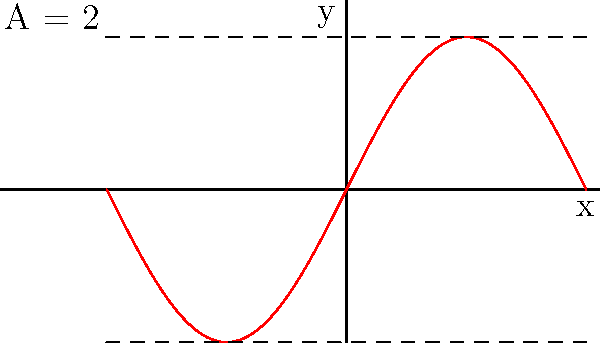Given the sine wave function $f(x) = 2\sin(x)$ plotted above, determine the amplitude of the wave. How would this amplitude change if the function was modified to $g(x) = 3\sin(x)$? To solve this problem, let's follow these steps:

1. Recall that the amplitude of a sine wave is the maximum vertical distance from the midline to the peak (or trough) of the wave.

2. For the given function $f(x) = 2\sin(x)$:
   - The coefficient of $\sin(x)$ is 2.
   - This coefficient determines the amplitude of the wave.
   - Therefore, the amplitude of $f(x)$ is 2.

3. We can verify this from the graph:
   - The wave oscillates between y = 2 and y = -2.
   - The distance from the midline (y = 0) to either extreme is 2.

4. For the modified function $g(x) = 3\sin(x)$:
   - The coefficient of $\sin(x)$ is now 3.
   - This means the new amplitude would be 3.
   - The wave would now oscillate between y = 3 and y = -3.

5. Comparing the two functions:
   - The amplitude of $g(x)$ is 1.5 times the amplitude of $f(x)$.
   - This is because 3 (the new coefficient) is 1.5 times 2 (the original coefficient).
Answer: The amplitude of $f(x)$ is 2. For $g(x)$, the amplitude would increase to 3. 